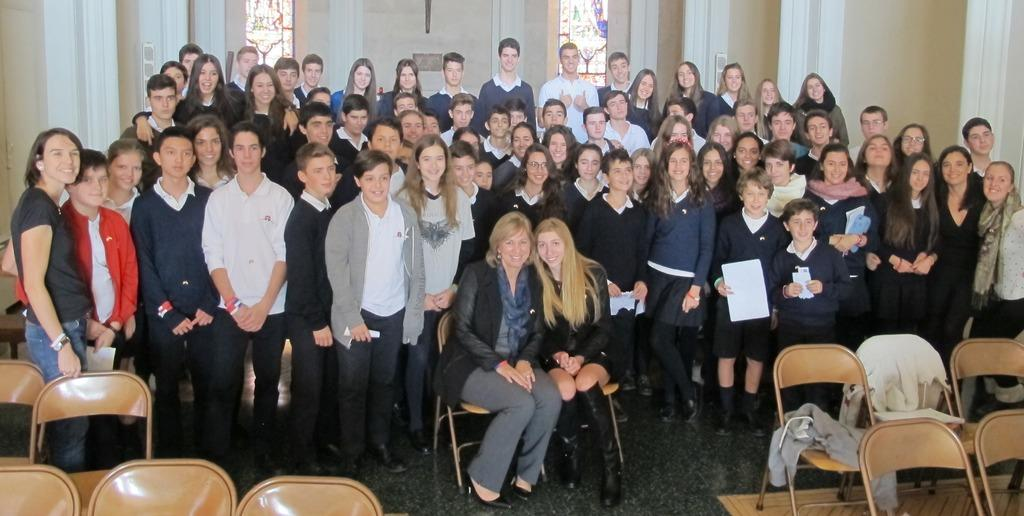What is the primary activity of the people in the image? The primary activity of the people in the image is standing or sitting. How many people are sitting in the image? There are two people sitting in chairs in the image. What is the status of the chairs in the front of the image? The chairs in the front of the image are empty. What impulse did the daughter feel when she saw the empty chairs in the image? There is no daughter present in the image, and therefore no impulse can be attributed to her. 